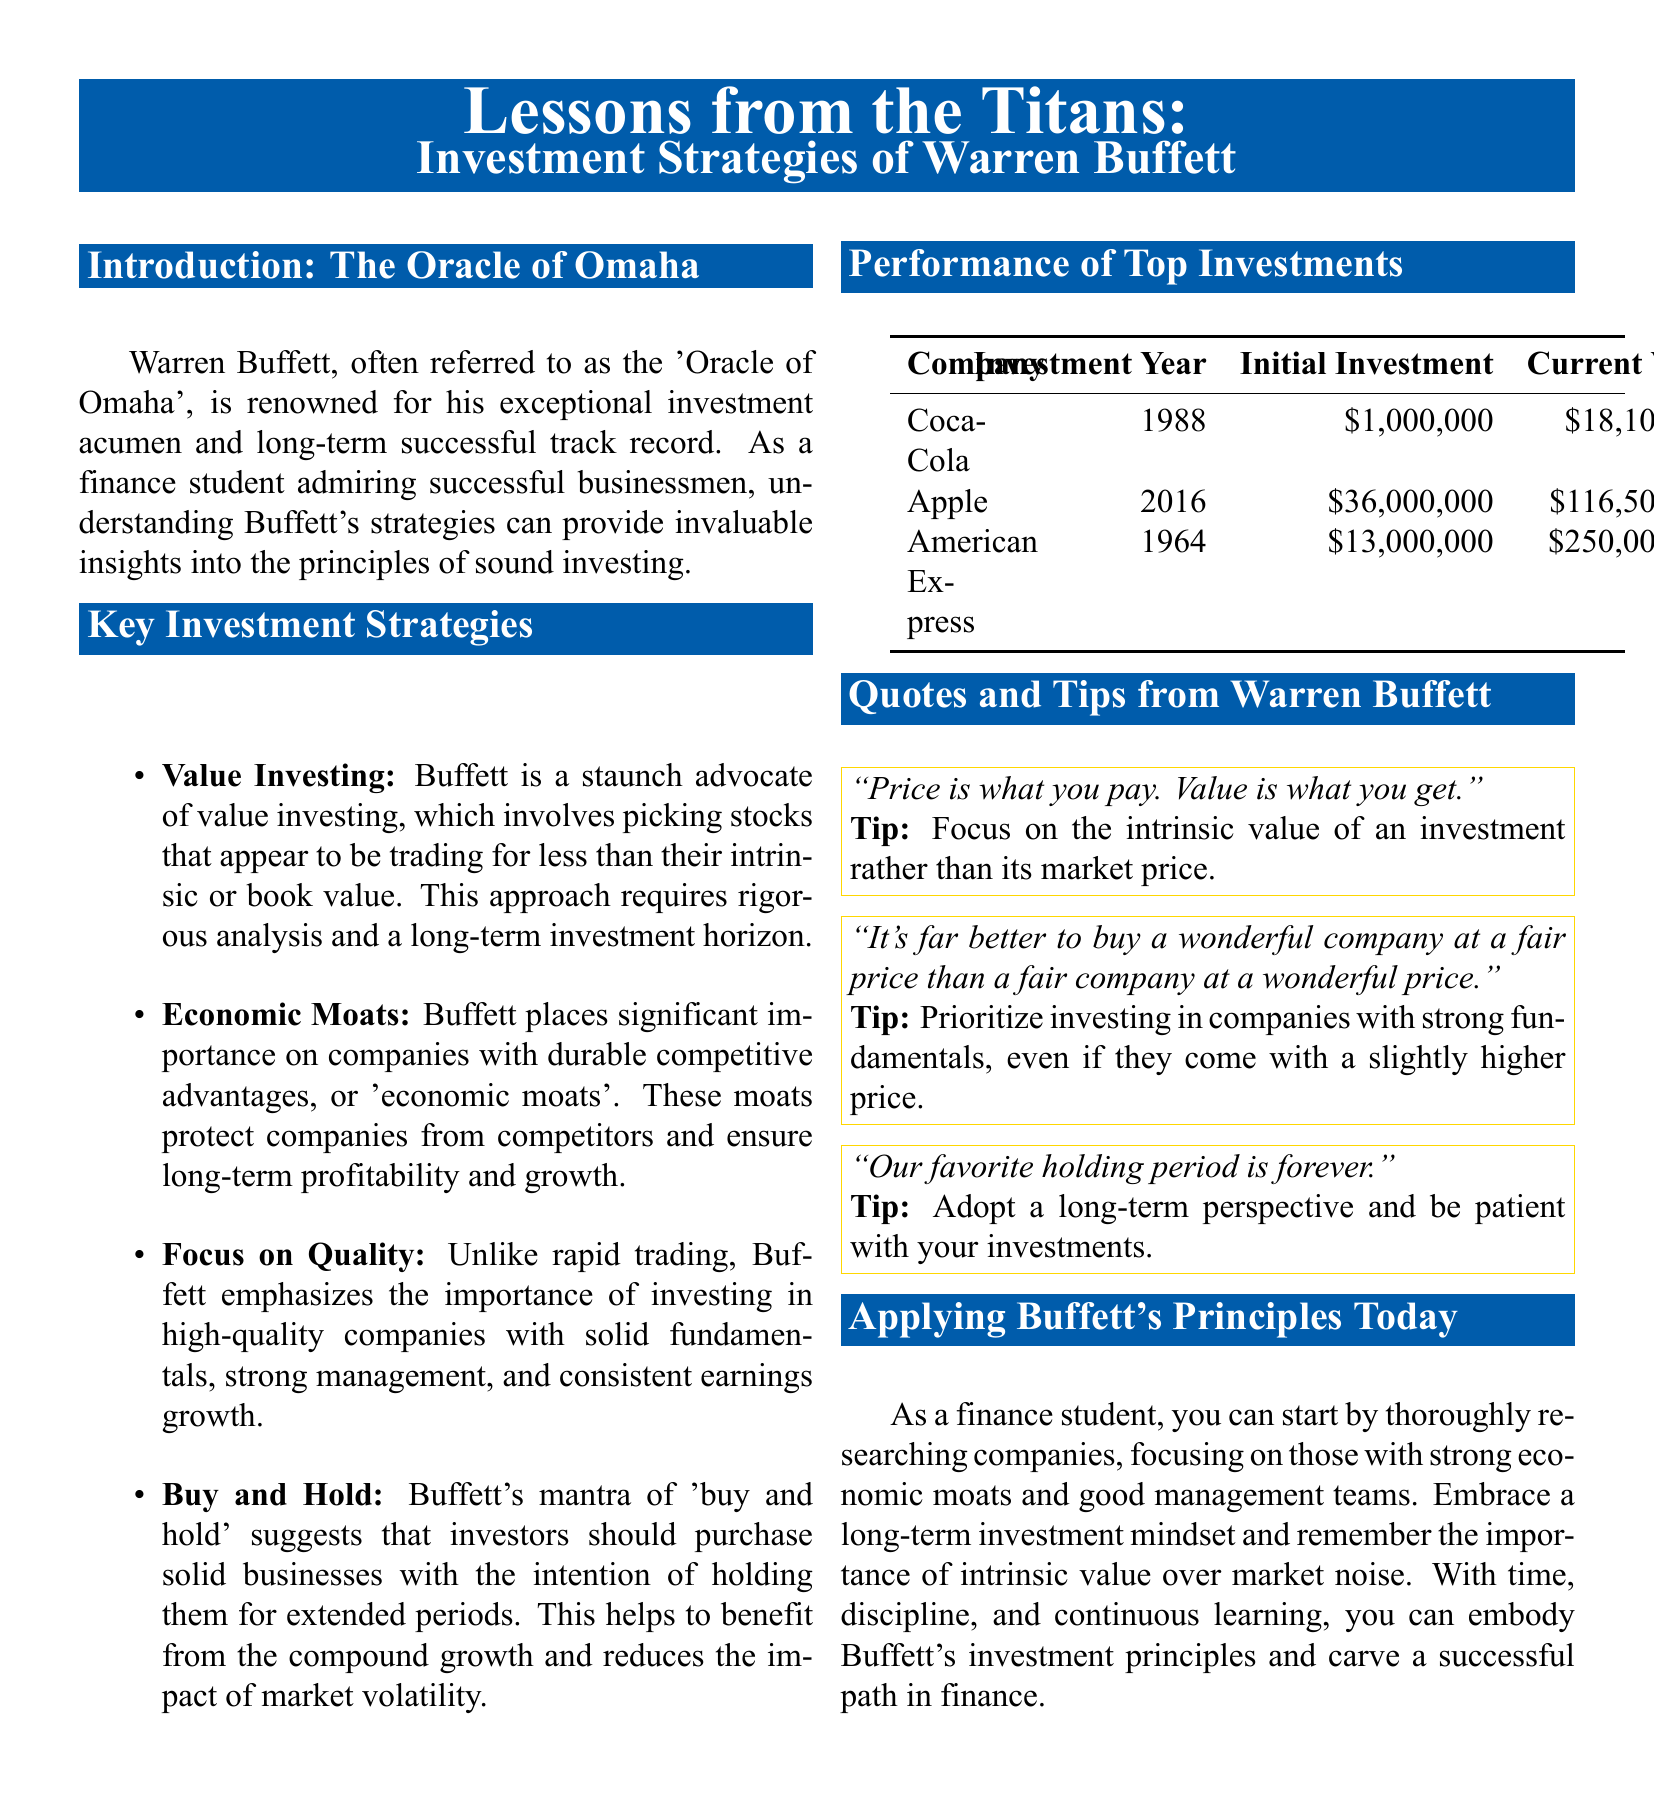What is the nickname of Warren Buffett? Warren Buffett is often referred to as the 'Oracle of Omaha', which is mentioned in the introduction section of the document.
Answer: Oracle of Omaha In which year did Buffett invest in Coca-Cola? The investment year for Coca-Cola is provided in the table of top investments in the document.
Answer: 1988 What is the current value of Buffett's investment in Apple? The current value of the investment in Apple is listed in the performance table of top investments.
Answer: $116,500,000 What is one of Buffett's key investment strategies? The document states various strategies, one of which is value investing, found in the key investment strategies section.
Answer: Value Investing What does Buffett mean by "Buy and Hold"? Buffett's philosophy of 'buy and hold' is explained in the context of his approach to investing in solid businesses for extended periods.
Answer: Buy solid businesses to hold long-term How much was the initial investment in American Express? The initial investment amount for American Express is provided in the table of investments.
Answer: $13,000,000 According to Buffett, what is more important, price or value? The document contains a quote from Buffett, emphasizing the importance of value over price.
Answer: Value What type of investment mindset should finance students adopt? The document advises students to embrace a long-term investment mindset as part of applying Buffett's principles today.
Answer: Long-term investment mindset 